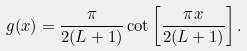Convert formula to latex. <formula><loc_0><loc_0><loc_500><loc_500>g ( x ) = \frac { \pi } { 2 ( L + 1 ) } \cot \left [ \frac { \pi x } { 2 ( L + 1 ) } \right ] .</formula> 